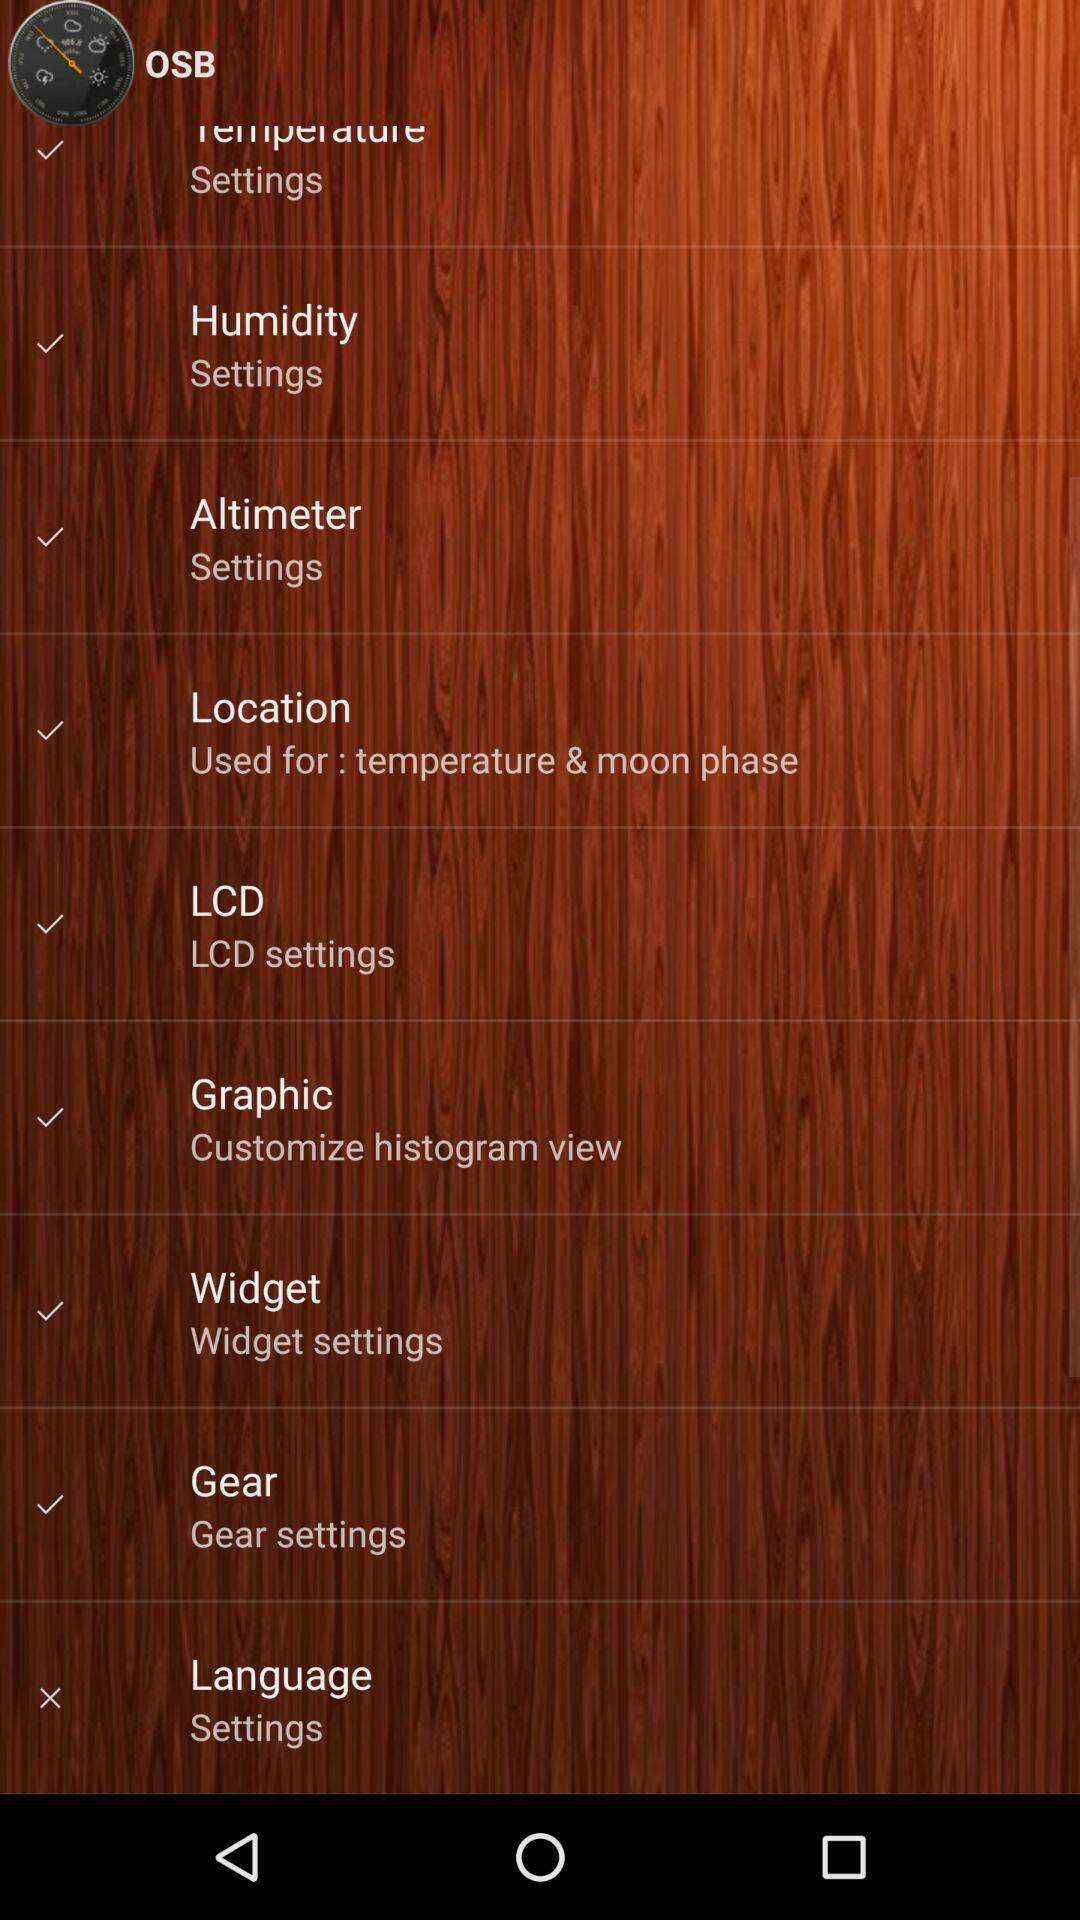What is the name of the application? The name of the application is "OSB". 